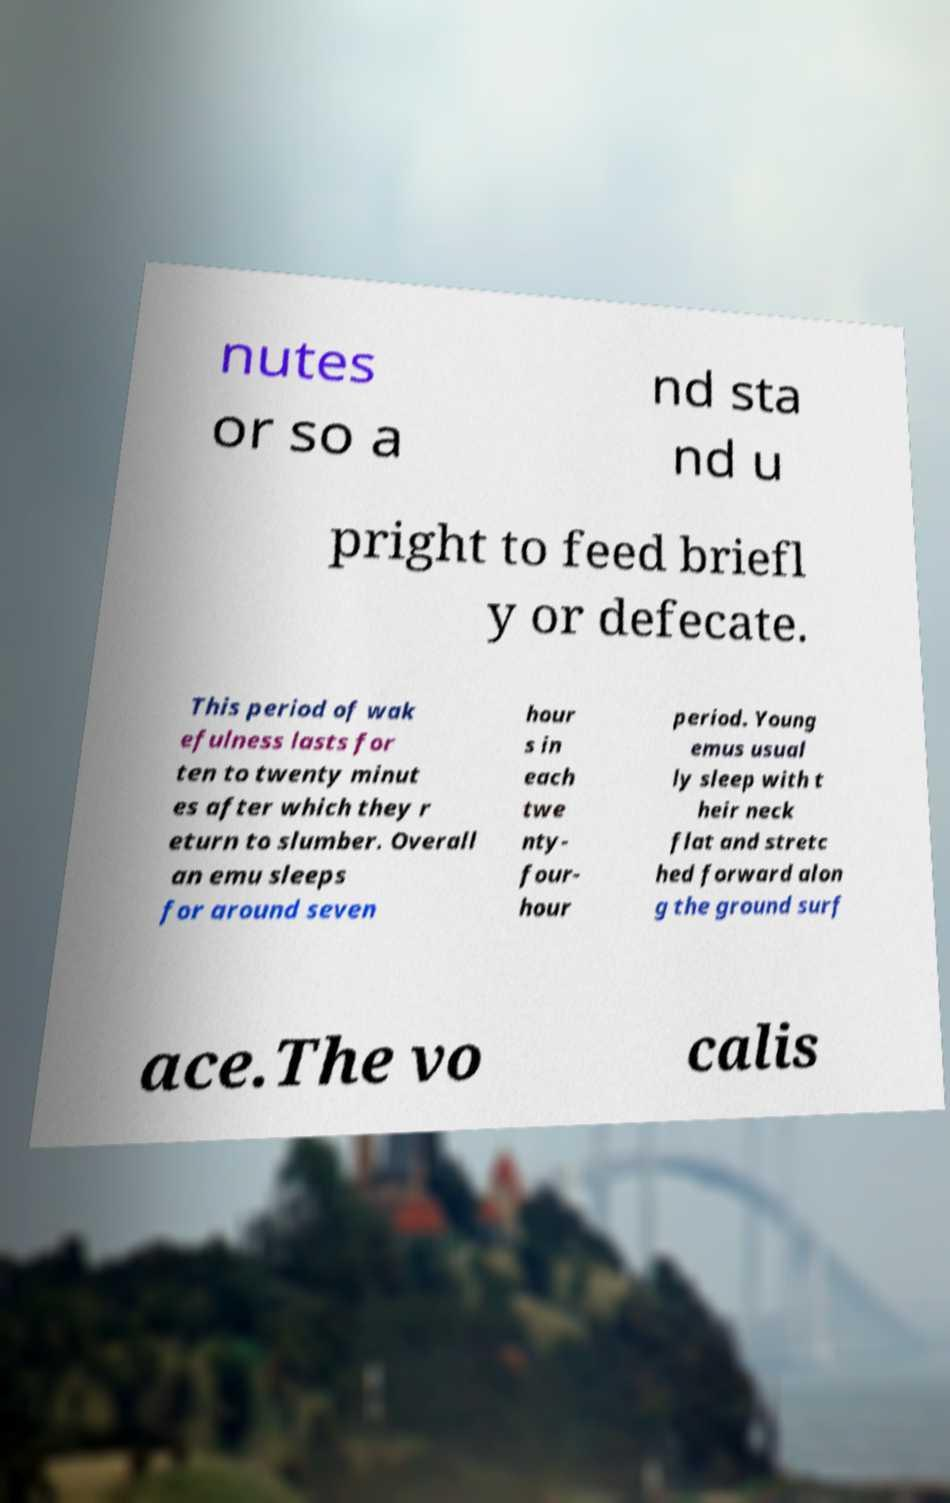Can you read and provide the text displayed in the image?This photo seems to have some interesting text. Can you extract and type it out for me? nutes or so a nd sta nd u pright to feed briefl y or defecate. This period of wak efulness lasts for ten to twenty minut es after which they r eturn to slumber. Overall an emu sleeps for around seven hour s in each twe nty- four- hour period. Young emus usual ly sleep with t heir neck flat and stretc hed forward alon g the ground surf ace.The vo calis 